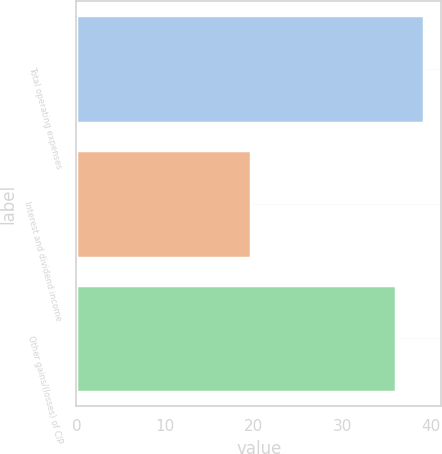Convert chart. <chart><loc_0><loc_0><loc_500><loc_500><bar_chart><fcel>Total operating expenses<fcel>Interest and dividend income<fcel>Other gains/(losses) of CIP<nl><fcel>39.2<fcel>19.7<fcel>36.1<nl></chart> 